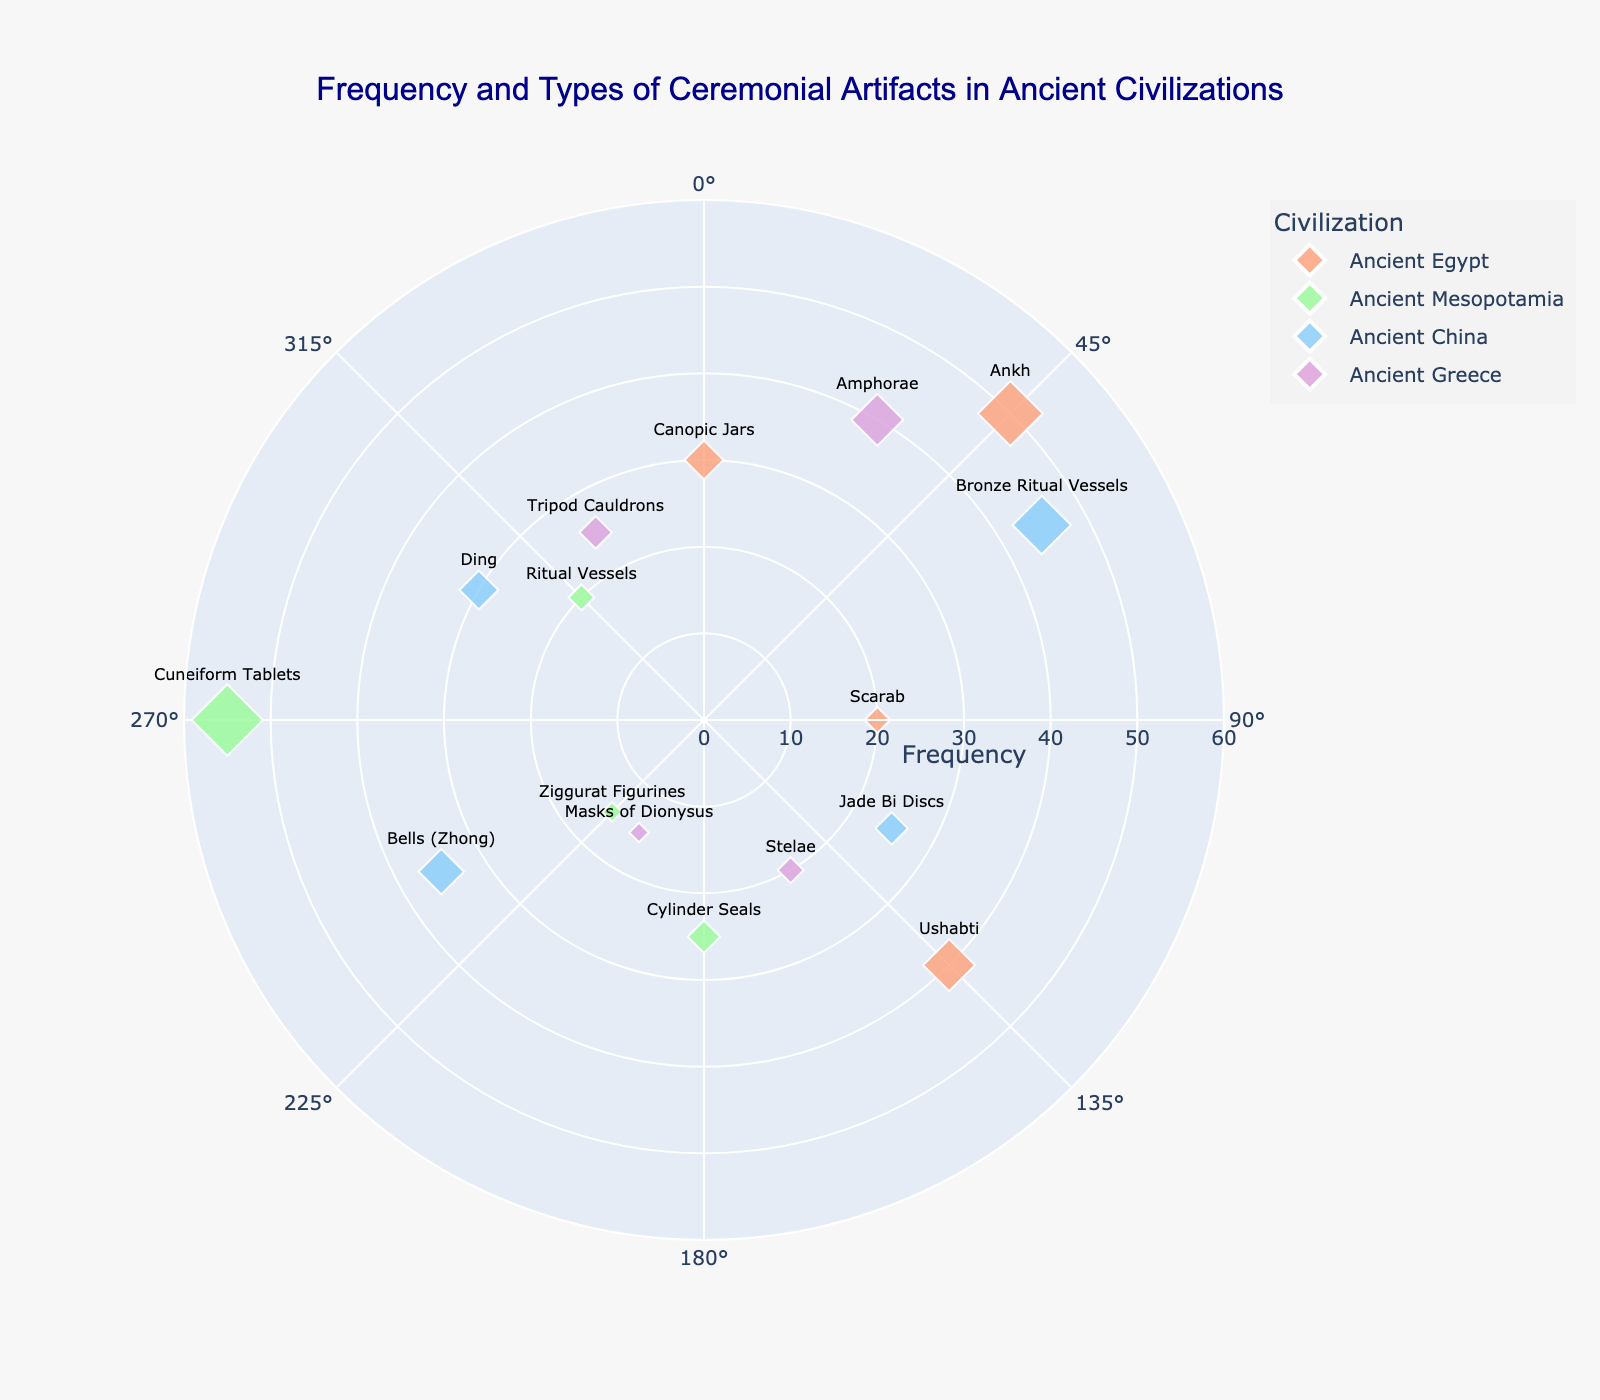How many different types of artifacts are depicted for Ancient Mesopotamia? Inspect the plot for the data points associated with Ancient Mesopotamia (green markers). There are 4 artifact types: Cylinder Seals, Ziggurat Figurines, Cuneiform Tablets, and Ritual Vessels.
Answer: 4 Which civilization has the highest frequency of a single type of artifact? Look for the largest data marker on the plot. Cuneiform Tablets from Ancient Mesopotamia has the highest frequency, represented by the largest green diamond.
Answer: Ancient Mesopotamia What is the most common ceremonial artifact from Ancient Egypt? Identify the markers for Ancient Egypt (salmon markers) and compare their sizes. The Ankh has the largest marker, indicating a frequency of 50, which is the highest for Ancient Egypt.
Answer: Ankh How do the frequencies of Ding and Canopic Jars compare? Locate the markers for Ding (Ancient China, frequency 30) and Canopic Jars (Ancient Egypt, frequency 30). They have equal-sized markers.
Answer: Equal What is the average frequency of artifacts from Ancient China? Identify the frequencies for Ancient China: Bronze Ritual Vessels (45), Jade Bi Discs (25), Bells (35), and Ding (30). Add them up: 45 + 25 + 35 + 30 = 135, then divide by the number of artifacts (4): 135 / 4 = 33.75.
Answer: 33.75 Which artifact types are shown at exactly 135 and 300 degrees? At 135 degrees, there is Ushabti (Ancient Egypt). At 300 degrees, there is Ding (Ancient China).
Answer: Ushabti and Ding Which civilization has the lowest frequency artifact and what is it? Locate the smallest markers on the plot. The smallest green diamond represents Ziggurat Figurines from Ancient Mesopotamia with a frequency of 15.
Answer: Ancient Mesopotamia, Ziggurat Figurines How many artifacts have a frequency greater than 40? Count the markers with a size indicating a frequency greater than 40: Ankh (50), Cuneiform Tablets (55), Bronze Ritual Vessels (45), and Amphorae (40+). There are 4 such markers.
Answer: 4 What is the total frequency of Greek artifacts on the plot? Identify: Amphorae (40), Stelae (20), Masks of Dionysus (15), Tripod Cauldrons (25). Sum the frequencies: 40 + 20 + 15 + 25 = 100.
Answer: 100 Which artifact types are specific to Ancient Greece? Inspect the legends or labels for Ancient Greece (purple markers) and identify the artifact types: Amphorae, Stelae, Masks of Dionysus, and Tripod Cauldrons.
Answer: Amphorae, Stelae, Masks of Dionysus, Tripod Cauldrons 